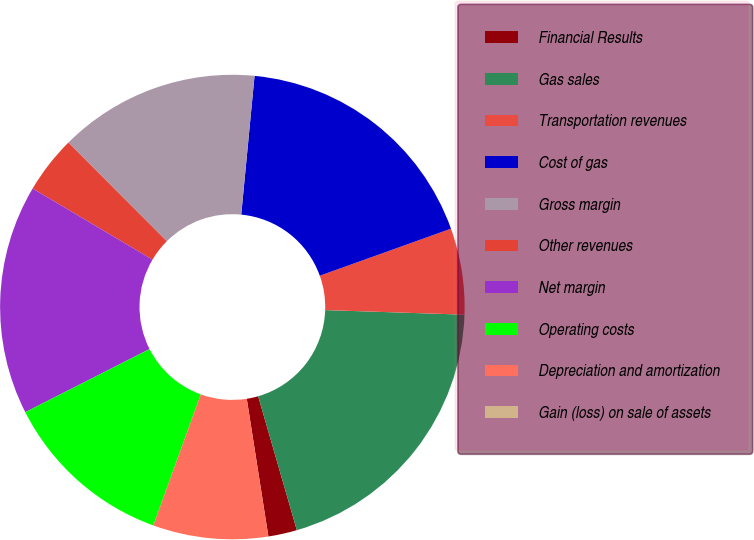Convert chart. <chart><loc_0><loc_0><loc_500><loc_500><pie_chart><fcel>Financial Results<fcel>Gas sales<fcel>Transportation revenues<fcel>Cost of gas<fcel>Gross margin<fcel>Other revenues<fcel>Net margin<fcel>Operating costs<fcel>Depreciation and amortization<fcel>Gain (loss) on sale of assets<nl><fcel>2.0%<fcel>20.0%<fcel>6.0%<fcel>18.0%<fcel>14.0%<fcel>4.0%<fcel>16.0%<fcel>12.0%<fcel>8.0%<fcel>0.0%<nl></chart> 